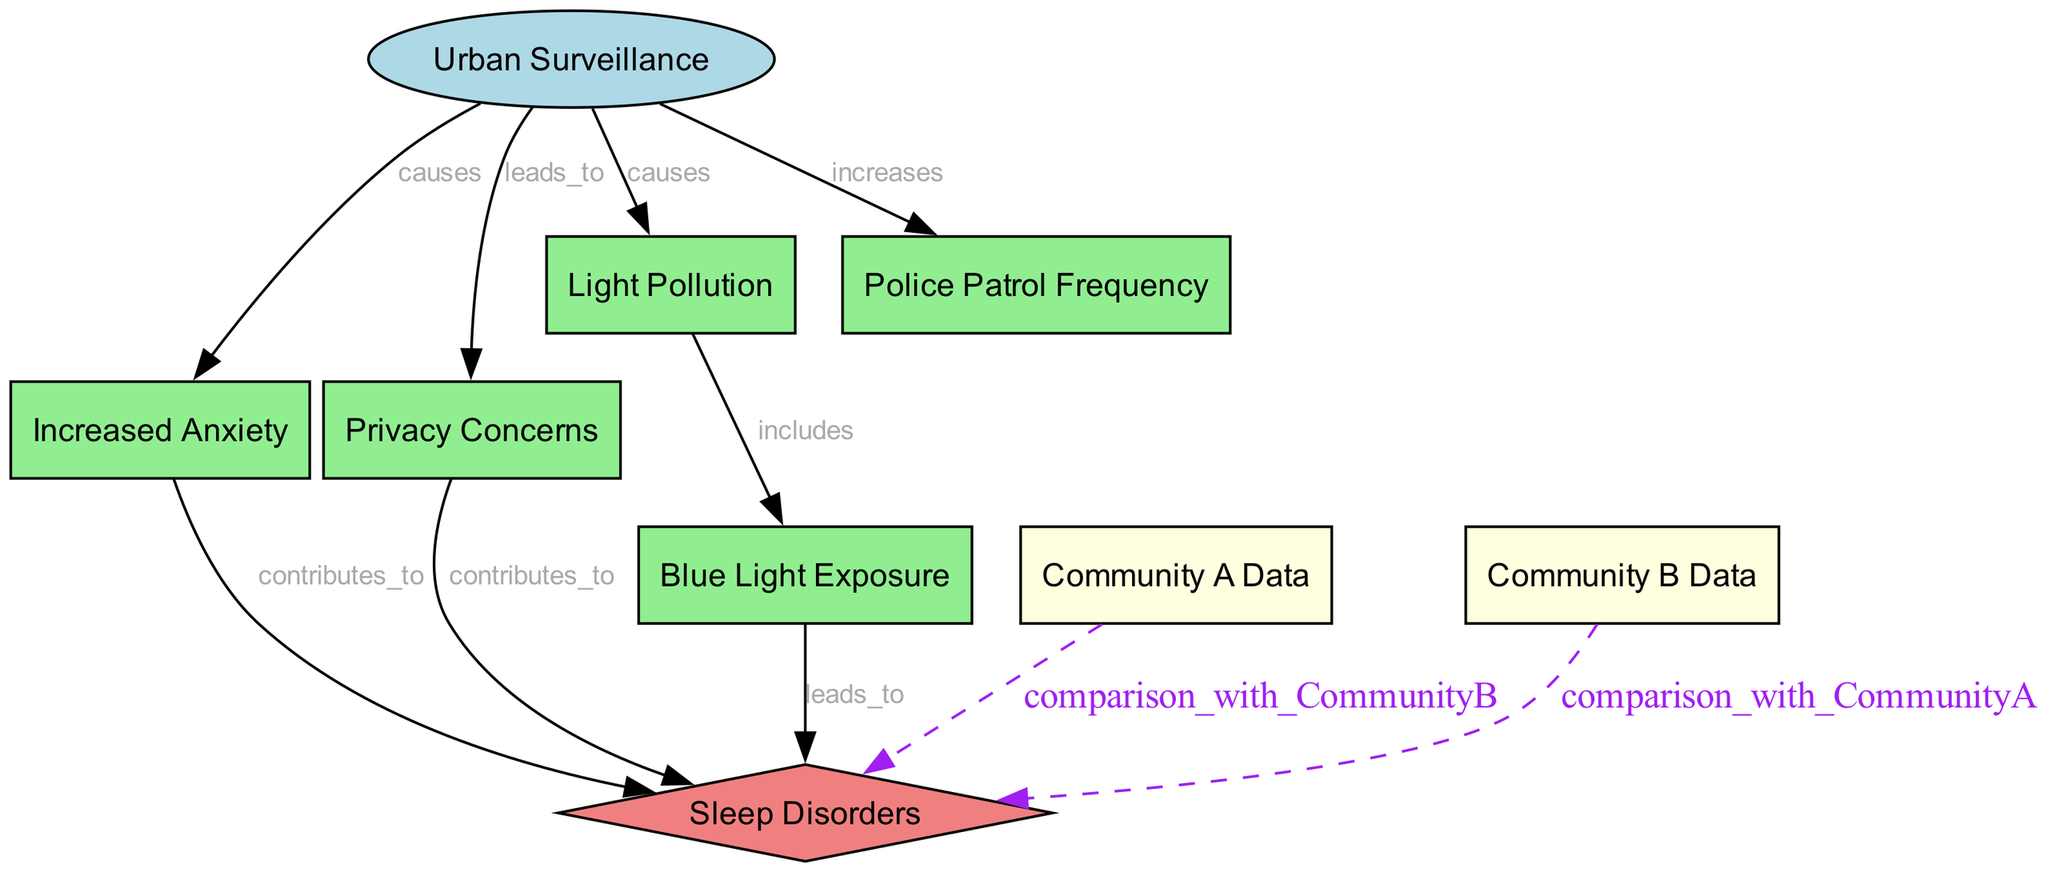What is the central node in the diagram? The central node is identified by analyzing the structure of the diagram where all the connections converge, which prominently centers around "Urban Surveillance".
Answer: Urban Surveillance How many nodes are present in the diagram? By counting each individual labeled shape in the diagram, we identify a total of nine distinct nodes, each representing a unique concept or data point.
Answer: Nine What contributes to sleep disorders according to the diagram? By examining the arrows and their labels, we can compile the contributing factors to sleep disorders: "Increased Anxiety," "Privacy Concerns," and "Blue Light Exposure."
Answer: Increased Anxiety, Privacy Concerns, Blue Light Exposure What does urban surveillance lead to, besides sleep disorders? We look for direct connections labeled coming from the "Urban Surveillance" node that are not directed towards sleep disorders, which shows "Increased Anxiety" and "Privacy Concerns" as clear outcomes.
Answer: Increased Anxiety, Privacy Concerns What type of pollution is caused by urban surveillance? The diagram displays a direct causal connection from "Urban Surveillance" to "Light Pollution," indicating that the introduction of surveillance systems contributes specifically to this type of environmental concern.
Answer: Light Pollution How is police patrol frequency related to urban surveillance? We analyze the edge connecting "Urban Surveillance" and "Police Patrol Frequency," which is marked as "increases," indicating that urban surveillance results in a higher frequency of police patrols in the area.
Answer: Increases What is the relationship between light pollution and blue light exposure? The diagram indicates a direct connection from "Light Pollution" to "Blue Light Exposure," meaning that light pollution often encompasses or includes blue light as a component.
Answer: Includes How do the data from Community A and Community B relate to sleep disorders? Each data point from "Community A Data" and "Community B Data" has a pathway to "Sleep Disorders," demonstrating the comparative nature of these datasets in assessing sleep issues across different communities.
Answer: Comparison with Community B, Comparison with Community A Which factor does NOT contribute to sleep disorders according to the diagram? Analyzing the factors labelled with arrows leading towards "Sleep Disorders" confirms that "Police Patrol Frequency" does not have any direct line linking it to sleep disorders, thus indicating it is not a contributing factor.
Answer: Police Patrol Frequency 